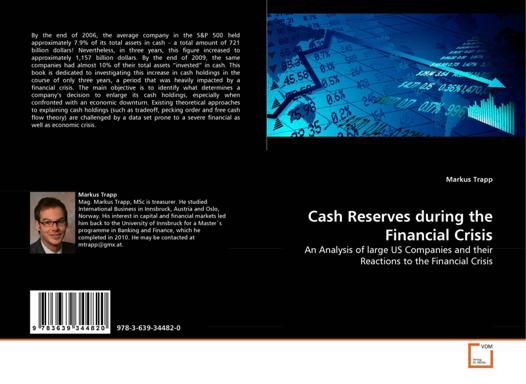What is the title of the book referenced in the image? The title of the book referenced in the image is "Cash Reserves during the Financial Crisis: An Analysis of large US Companies and their Reactions to the Financial Crisis" by Markus Trapp. What is the ISBN number of the book? The ISBN number of the book is 978-3-639-34482-0. 